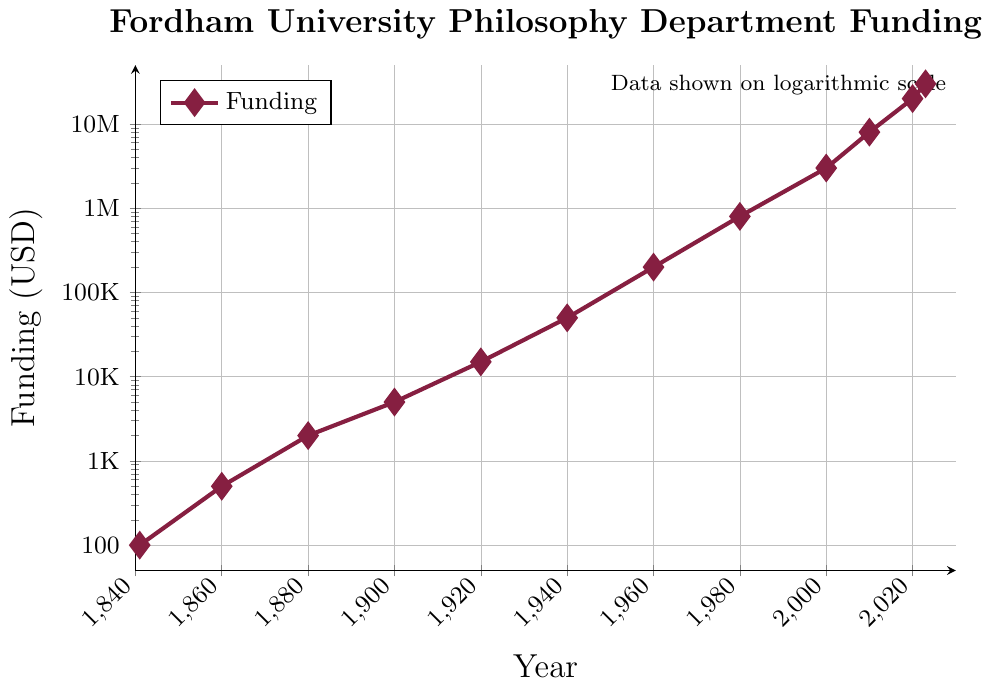What is the range of the funding amounts shown in the plot? The minimum funding amount is 100 USD in 1841, and the maximum funding amount is 30,000,000 USD in 2023. The range is the difference between the maximum and minimum values, which is 30,000,000 - 100 = 29,999,900 USD.
Answer: 29,999,900 USD During which periods did the funding amount increase by a factor of 10? To determine the periods during which funding increased by a factor of 10, look for points where the funding at a later year is 10 times that of an earlier year. Between 1940 and 1960, the funding increased from 50,000 USD to 200,000 USD. Between 1960 and 1980, the funding increased from 200,000 USD to 800,000 USD. Finally, between 1980 and 2000, the funding increased from 800,000 USD to 3,000,000 USD.
Answer: 1940-1960, 1960-1980, 1980-2000 What is the percentage increase in funding from 2000 to 2020? First, calculate the increase in funding from 2000 to 2020, which is 20,000,000 - 3,000,000 = 17,000,000 USD. The percentage increase is then (17,000,000 / 3,000,000) * 100 = 566.67%.
Answer: 566.67% By what factor did the funding increase from its founding in 1841 to 2023? To find the factor, divide the funding in 2023 by the funding in 1841. That is 30,000,000 / 100 = 300,000.
Answer: 300,000 Which year saw the highest single jump in funding compared to the previous recorded year? Look at the differences in funding between consecutive years shown. The largest increase is from 2010 to 2020, with an increase from 8,000,000 USD to 20,000,000 USD, a change of 12,000,000 USD.
Answer: 2010 to 2020 